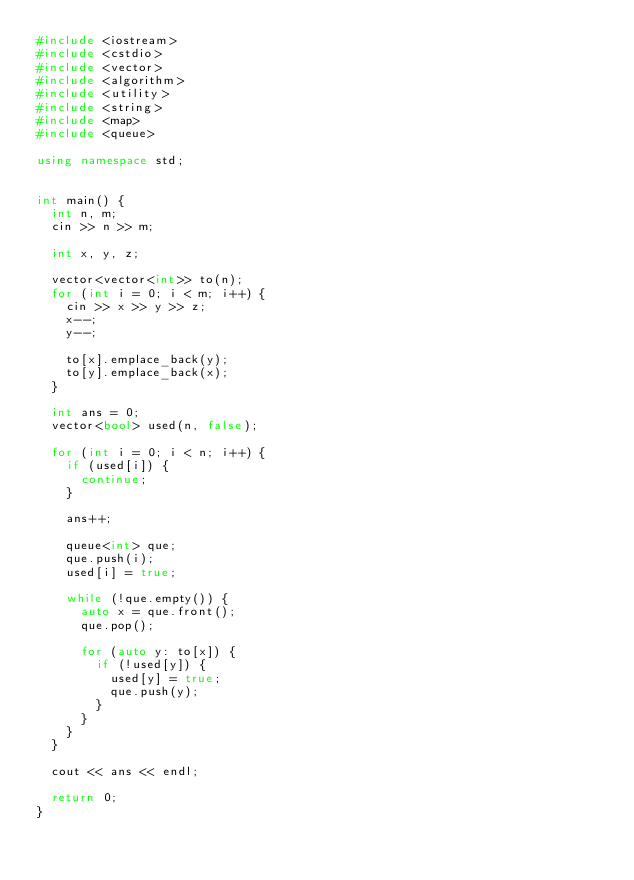<code> <loc_0><loc_0><loc_500><loc_500><_C++_>#include <iostream>
#include <cstdio>
#include <vector>
#include <algorithm>
#include <utility>
#include <string>
#include <map>
#include <queue>

using namespace std;


int main() {
	int n, m;
	cin >> n >> m;

	int x, y, z;

	vector<vector<int>> to(n);
	for (int i = 0; i < m; i++) {
		cin >> x >> y >> z;
		x--;
		y--;

		to[x].emplace_back(y);
		to[y].emplace_back(x);
	}

	int ans = 0;
	vector<bool> used(n, false);

	for (int i = 0; i < n; i++) {
		if (used[i]) {
			continue;
		}

		ans++;

		queue<int> que;
		que.push(i);
		used[i] = true;

		while (!que.empty()) {
			auto x = que.front();
			que.pop();

			for (auto y: to[x]) {
				if (!used[y]) {
					used[y] = true;
					que.push(y);
				}
			}
		}
	}

	cout << ans << endl;

	return 0;
}
</code> 